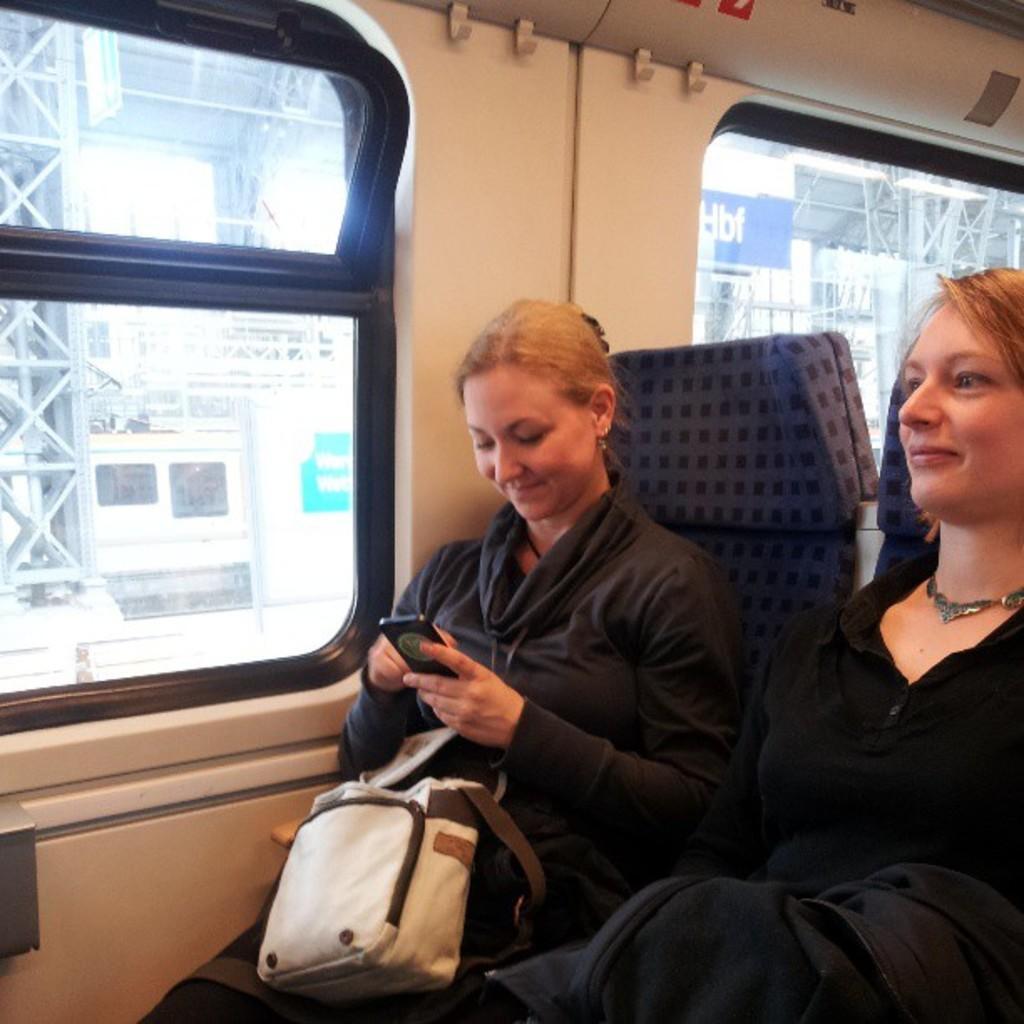Could you give a brief overview of what you see in this image? In this image I can see two women are sitting on the chairs, on the left side there is the glass window, it looks like an inside part of a train. 